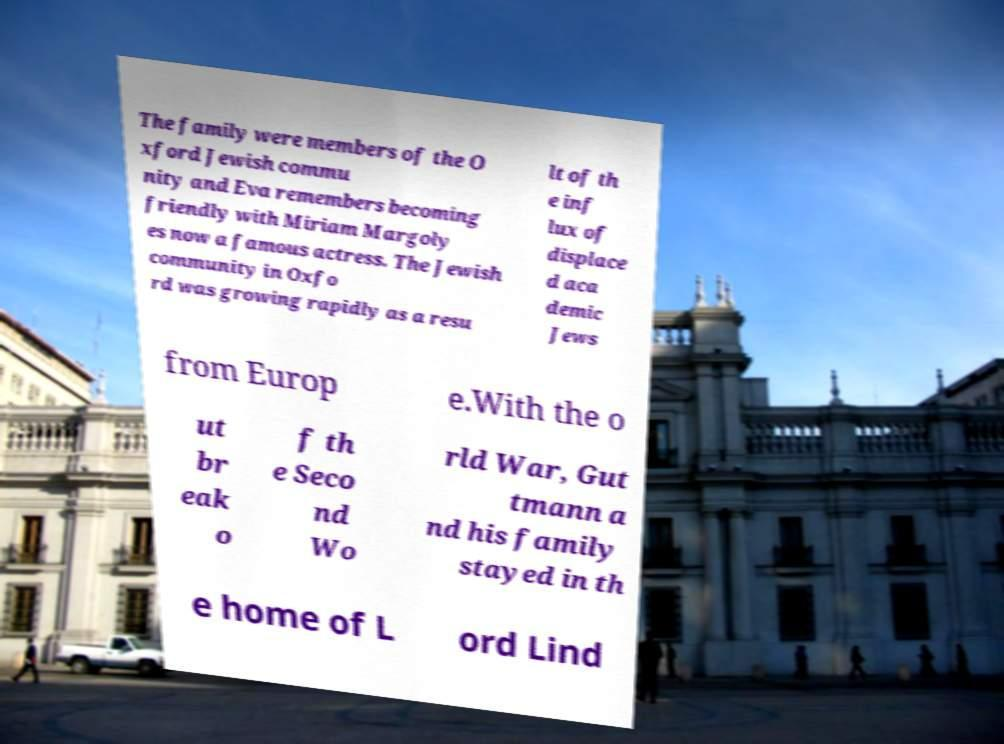There's text embedded in this image that I need extracted. Can you transcribe it verbatim? The family were members of the O xford Jewish commu nity and Eva remembers becoming friendly with Miriam Margoly es now a famous actress. The Jewish community in Oxfo rd was growing rapidly as a resu lt of th e inf lux of displace d aca demic Jews from Europ e.With the o ut br eak o f th e Seco nd Wo rld War, Gut tmann a nd his family stayed in th e home of L ord Lind 